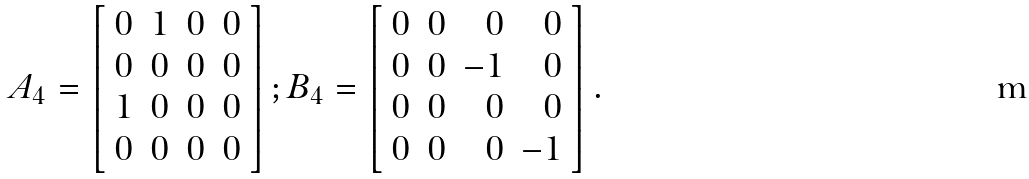<formula> <loc_0><loc_0><loc_500><loc_500>A _ { 4 } = \left [ \begin{array} { r r r r } 0 & 1 & 0 & 0 \\ 0 & 0 & 0 & 0 \\ 1 & 0 & 0 & 0 \\ 0 & 0 & 0 & 0 \\ \end{array} \right ] ; B _ { 4 } = \left [ \begin{array} { r r r r } 0 & 0 & 0 & 0 \\ 0 & 0 & - 1 & 0 \\ 0 & 0 & 0 & 0 \\ 0 & 0 & 0 & - 1 \\ \end{array} \right ] .</formula> 